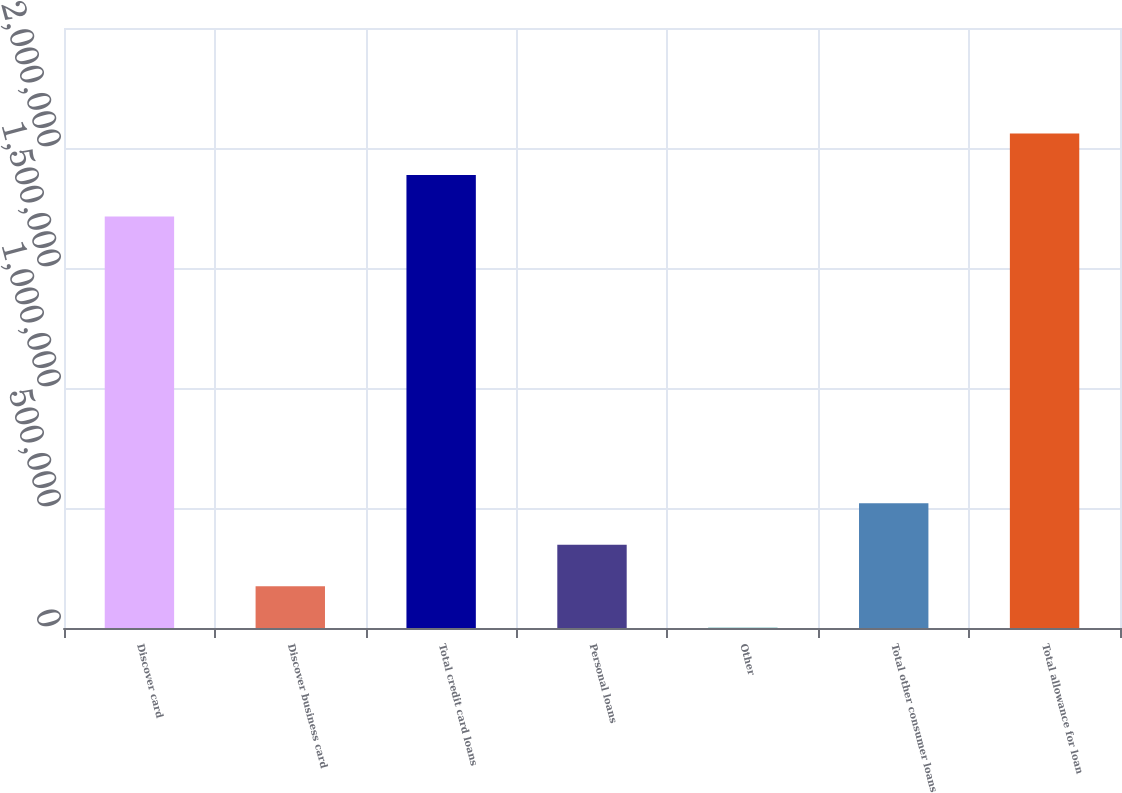<chart> <loc_0><loc_0><loc_500><loc_500><bar_chart><fcel>Discover card<fcel>Discover business card<fcel>Total credit card loans<fcel>Personal loans<fcel>Other<fcel>Total other consumer loans<fcel>Total allowance for loan<nl><fcel>1.71424e+06<fcel>173678<fcel>1.88735e+06<fcel>346786<fcel>569<fcel>519895<fcel>2.06045e+06<nl></chart> 